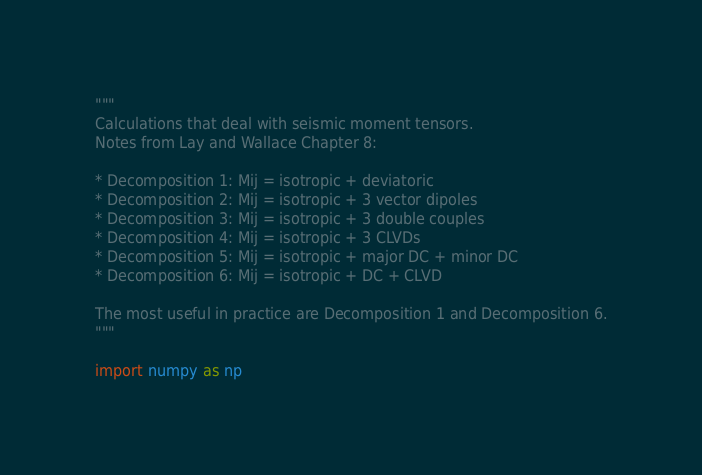<code> <loc_0><loc_0><loc_500><loc_500><_Python_>"""
Calculations that deal with seismic moment tensors.
Notes from Lay and Wallace Chapter 8:

* Decomposition 1: Mij = isotropic + deviatoric
* Decomposition 2: Mij = isotropic + 3 vector dipoles
* Decomposition 3: Mij = isotropic + 3 double couples
* Decomposition 4: Mij = isotropic + 3 CLVDs
* Decomposition 5: Mij = isotropic + major DC + minor DC
* Decomposition 6: Mij = isotropic + DC + CLVD

The most useful in practice are Decomposition 1 and Decomposition 6.
"""

import numpy as np
</code> 